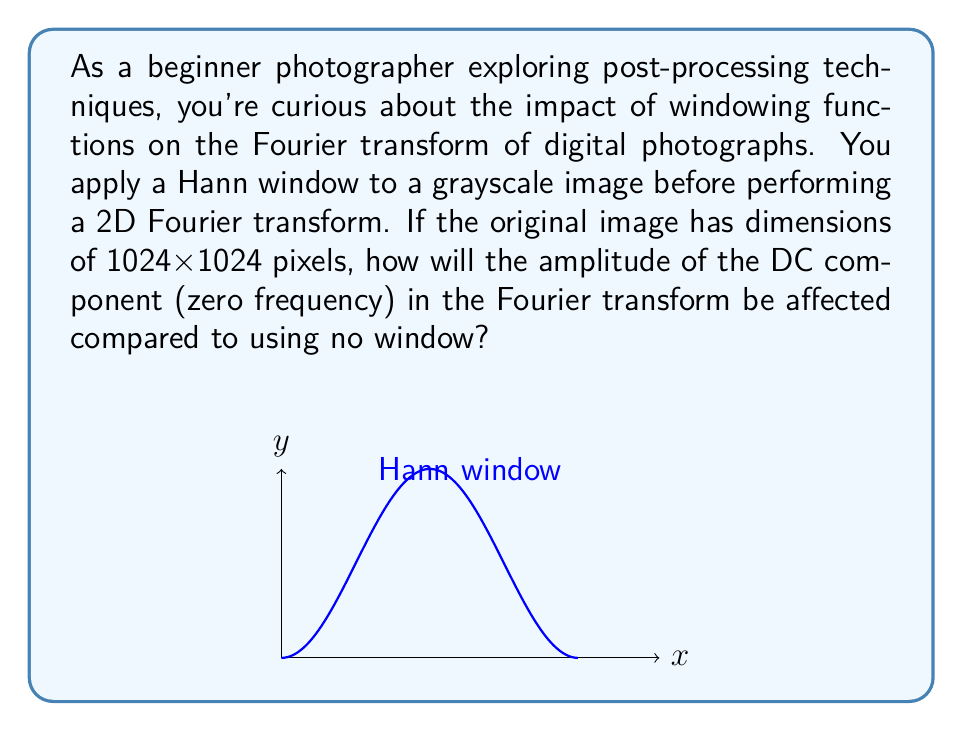Teach me how to tackle this problem. To understand the impact of the Hann window on the Fourier transform's DC component, let's follow these steps:

1) The Hann window function is defined as:

   $$w(n) = 0.5 \left(1 - \cos\left(\frac{2\pi n}{N-1}\right)\right)$$

   where $N$ is the window length.

2) For a 2D image, we apply this window in both dimensions:

   $$w(x,y) = w(x)w(y)$$

3) The DC component represents the average value of the image. When we apply a window, we're essentially scaling each pixel value by the window function before the Fourier transform.

4) The effect on the DC component can be calculated by finding the average value of the 2D window function:

   $$\text{DC scaling} = \frac{1}{N^2}\sum_{x=0}^{N-1}\sum_{y=0}^{N-1}w(x,y)$$

5) For large N, this sum approximates to the integral of the continuous 2D Hann window over [0,1]x[0,1]:

   $$\text{DC scaling} \approx \int_0^1\int_0^1 0.25(1-\cos(2\pi x))(1-\cos(2\pi y)) \, dx \, dy$$

6) Solving this integral:

   $$\text{DC scaling} = 0.25 \cdot 1 \cdot 1 = 0.25$$

7) This means that the amplitude of the DC component will be reduced to approximately 25% of its original value.
Answer: The DC component's amplitude will be reduced to approximately 25% of its original value. 